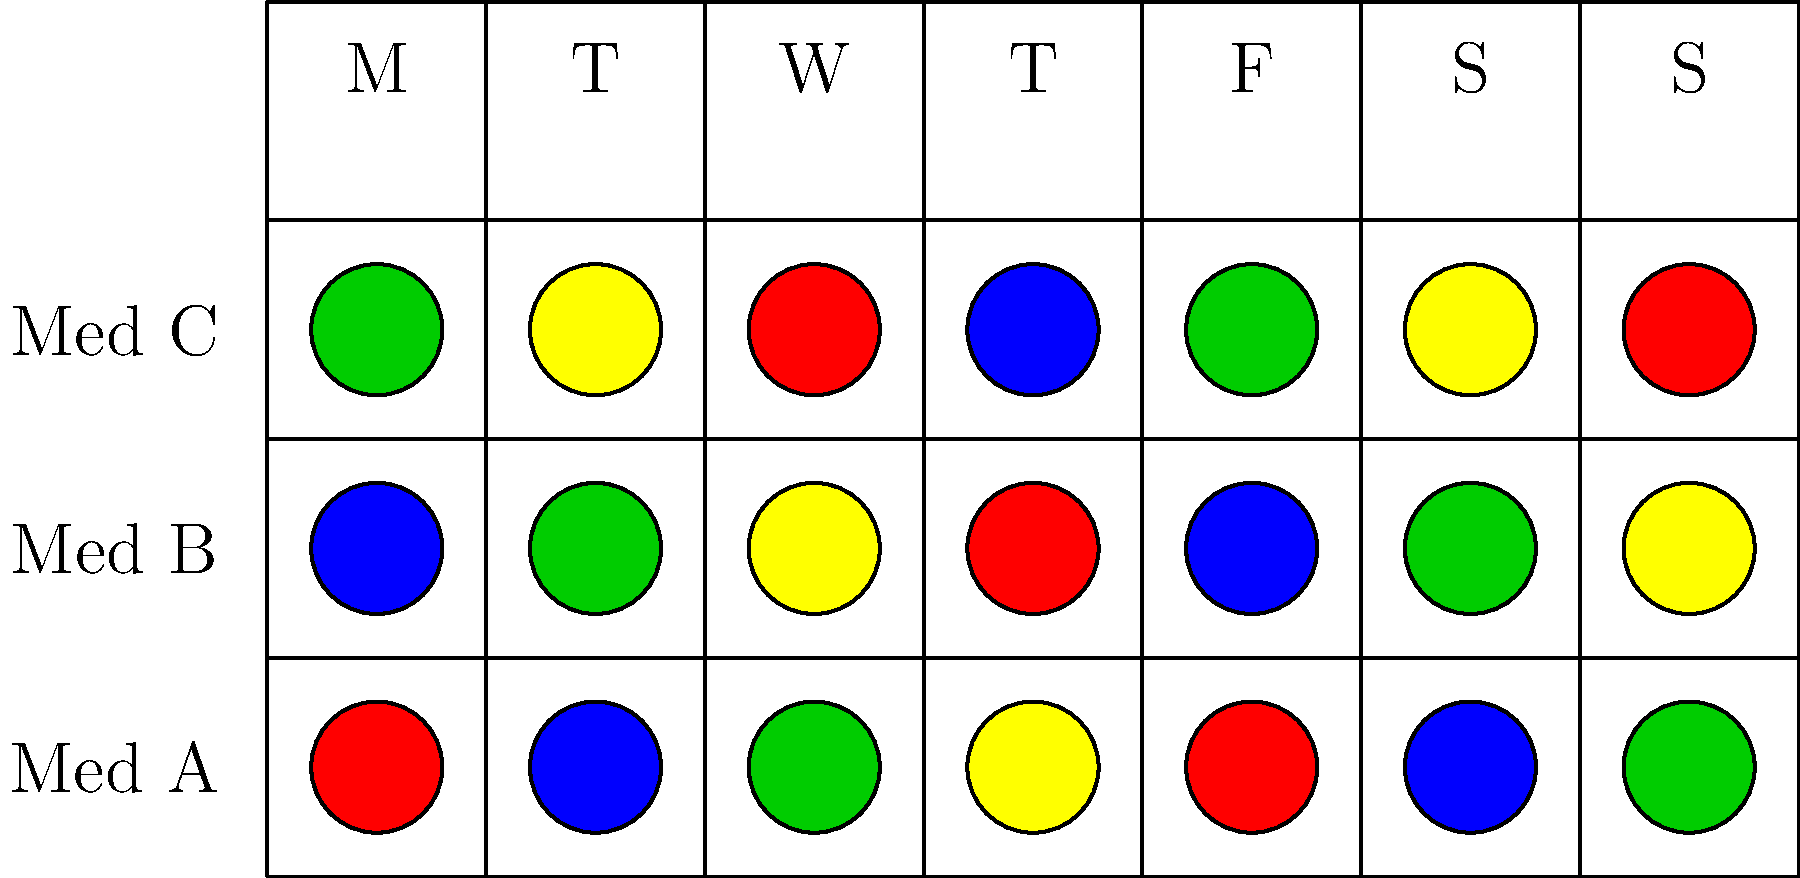Based on the color-coded medication schedule shown, which medication (A, B, or C) needs to be taken most frequently throughout the week, and on how many days? To solve this puzzle, we need to count the number of days each medication is taken:

1. Medication A (top row):
   - Taken on all 7 days of the week

2. Medication B (middle row):
   - Taken on all 7 days of the week

3. Medication C (bottom row):
   - Taken on all 7 days of the week

All medications are taken every day of the week. However, the question asks for the medication taken most frequently, so we need to consider if any medication is taken multiple times per day.

Looking at the color pattern:
- Medication A has no repeating colors on any day
- Medication B has no repeating colors on any day
- Medication C has no repeating colors on any day

Since there are no repeating colors for any medication on any day, all medications are taken once daily, every day of the week.

Therefore, all medications (A, B, and C) are taken with equal frequency, which is 7 days per week.
Answer: All (A, B, C); 7 days 